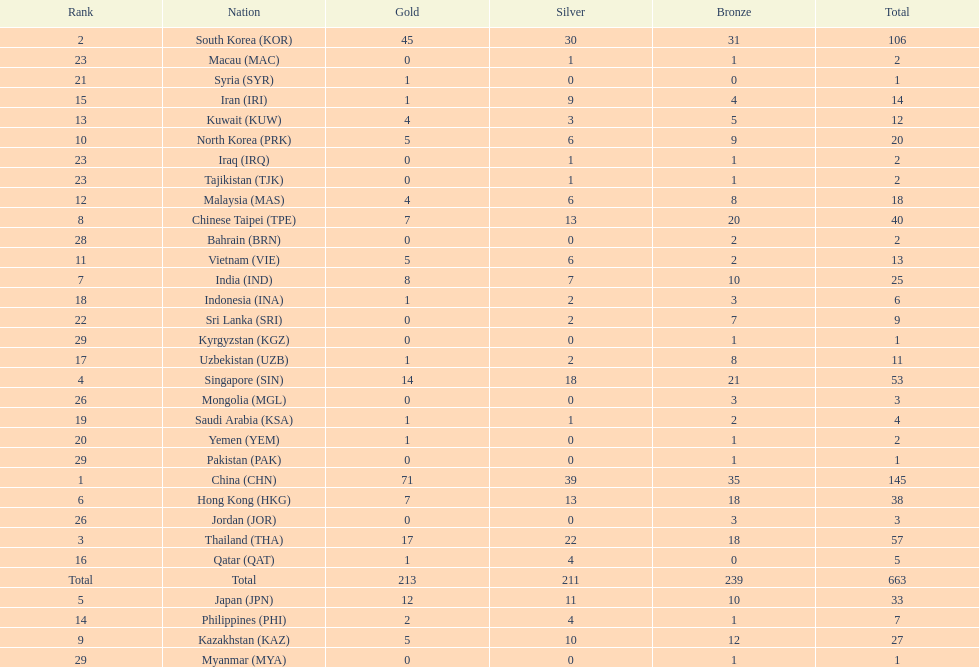Which countries have the same number of silver medals in the asian youth games as north korea? Vietnam (VIE), Malaysia (MAS). 